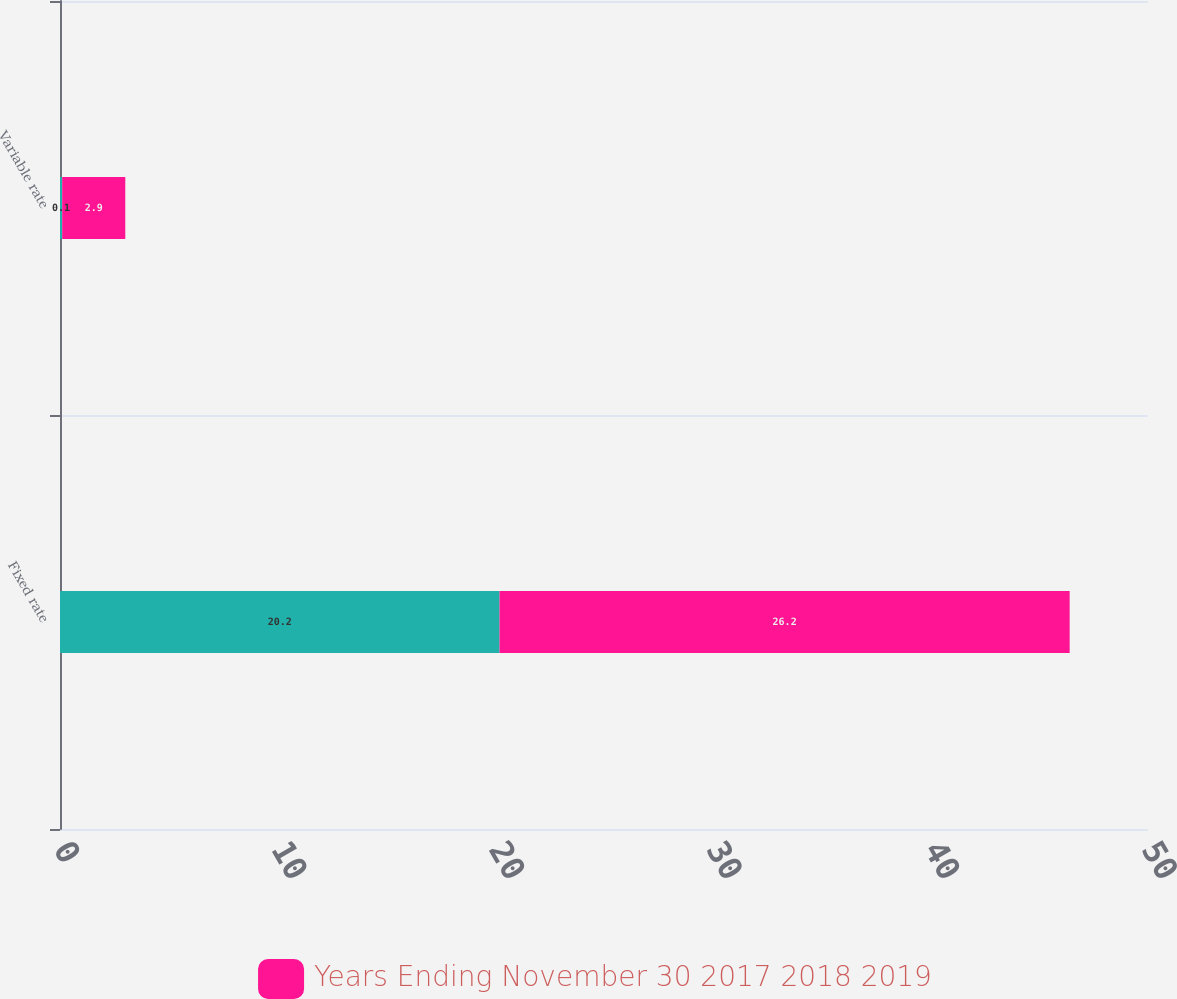Convert chart. <chart><loc_0><loc_0><loc_500><loc_500><stacked_bar_chart><ecel><fcel>Fixed rate<fcel>Variable rate<nl><fcel>nan<fcel>20.2<fcel>0.1<nl><fcel>Years Ending November 30 2017 2018 2019<fcel>26.2<fcel>2.9<nl></chart> 